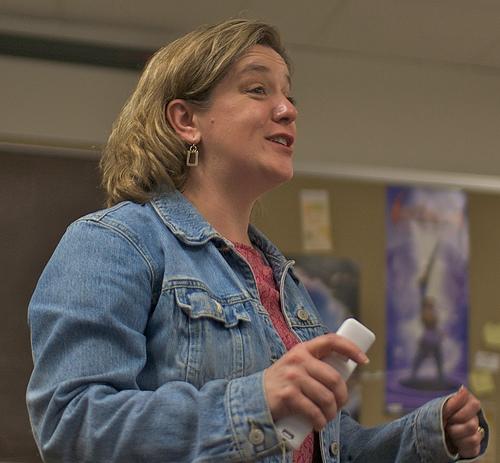Is the lady wearing earrings?
Write a very short answer. Yes. How many faces are visible?
Keep it brief. 1. What kind of jacket is she wearing?
Keep it brief. Jean. What is her name?
Quick response, please. Karen. What color hair does she have?
Be succinct. Blonde. Is the lady happy?
Concise answer only. Yes. What type of artwork is on the wall?
Short answer required. Poster. What does the woman have on her shoulder's?
Write a very short answer. Jacket. 